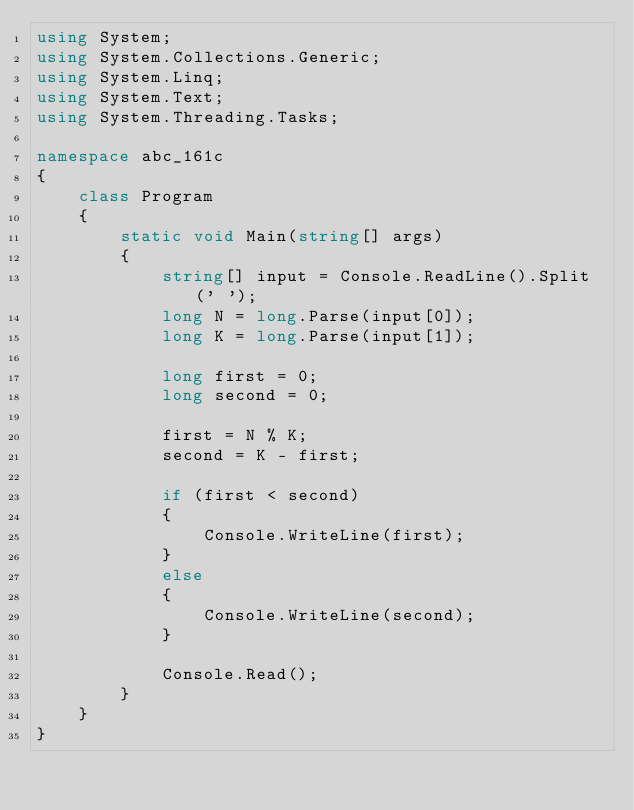<code> <loc_0><loc_0><loc_500><loc_500><_C#_>using System;
using System.Collections.Generic;
using System.Linq;
using System.Text;
using System.Threading.Tasks;

namespace abc_161c
{
    class Program
    {
        static void Main(string[] args)
        {
            string[] input = Console.ReadLine().Split(' ');
            long N = long.Parse(input[0]);
            long K = long.Parse(input[1]);

            long first = 0;
            long second = 0;
            
            first = N % K;
            second = K - first;

            if (first < second)
            {
                Console.WriteLine(first);
            }
            else
            {
                Console.WriteLine(second);
            }

            Console.Read();
        }
    }
}
</code> 